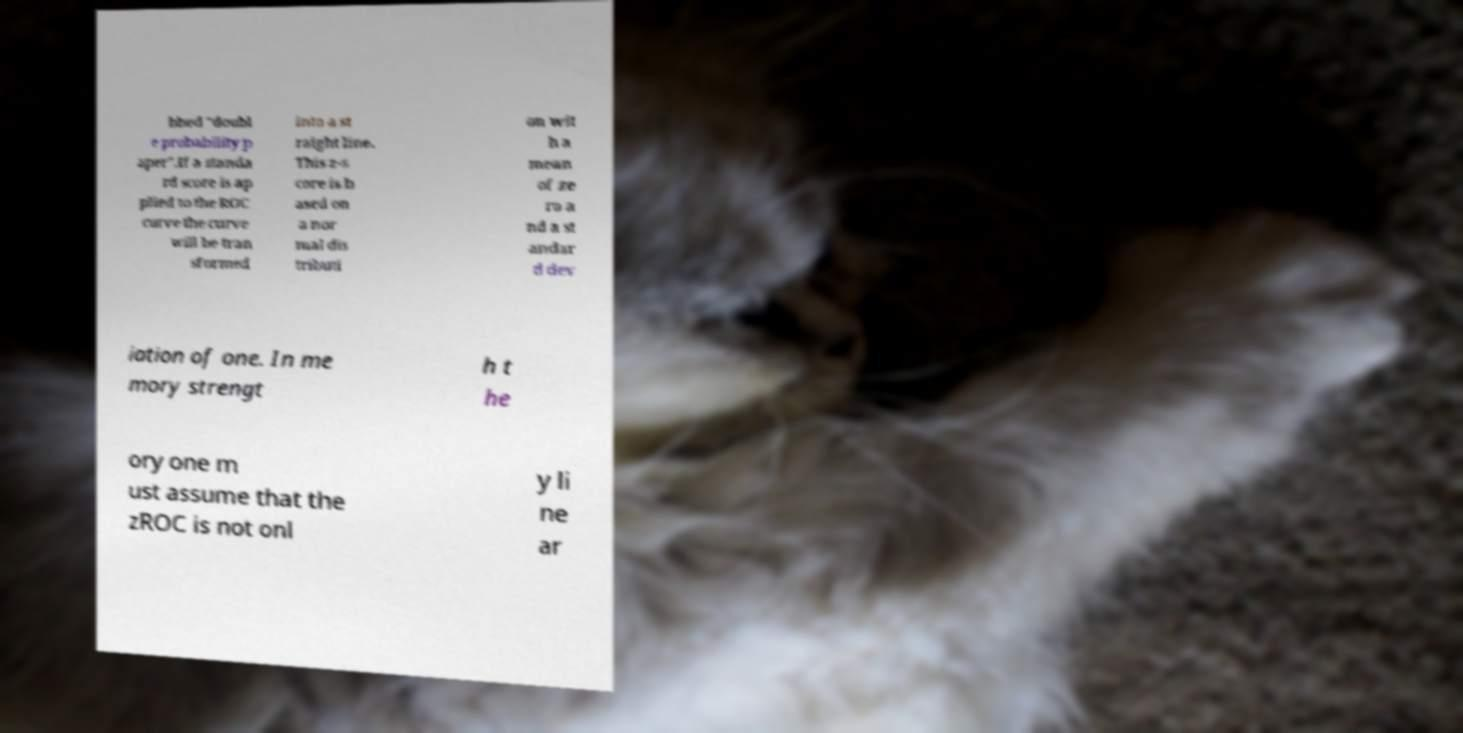Could you extract and type out the text from this image? bbed "doubl e probability p aper".If a standa rd score is ap plied to the ROC curve the curve will be tran sformed into a st raight line. This z-s core is b ased on a nor mal dis tributi on wit h a mean of ze ro a nd a st andar d dev iation of one. In me mory strengt h t he ory one m ust assume that the zROC is not onl y li ne ar 